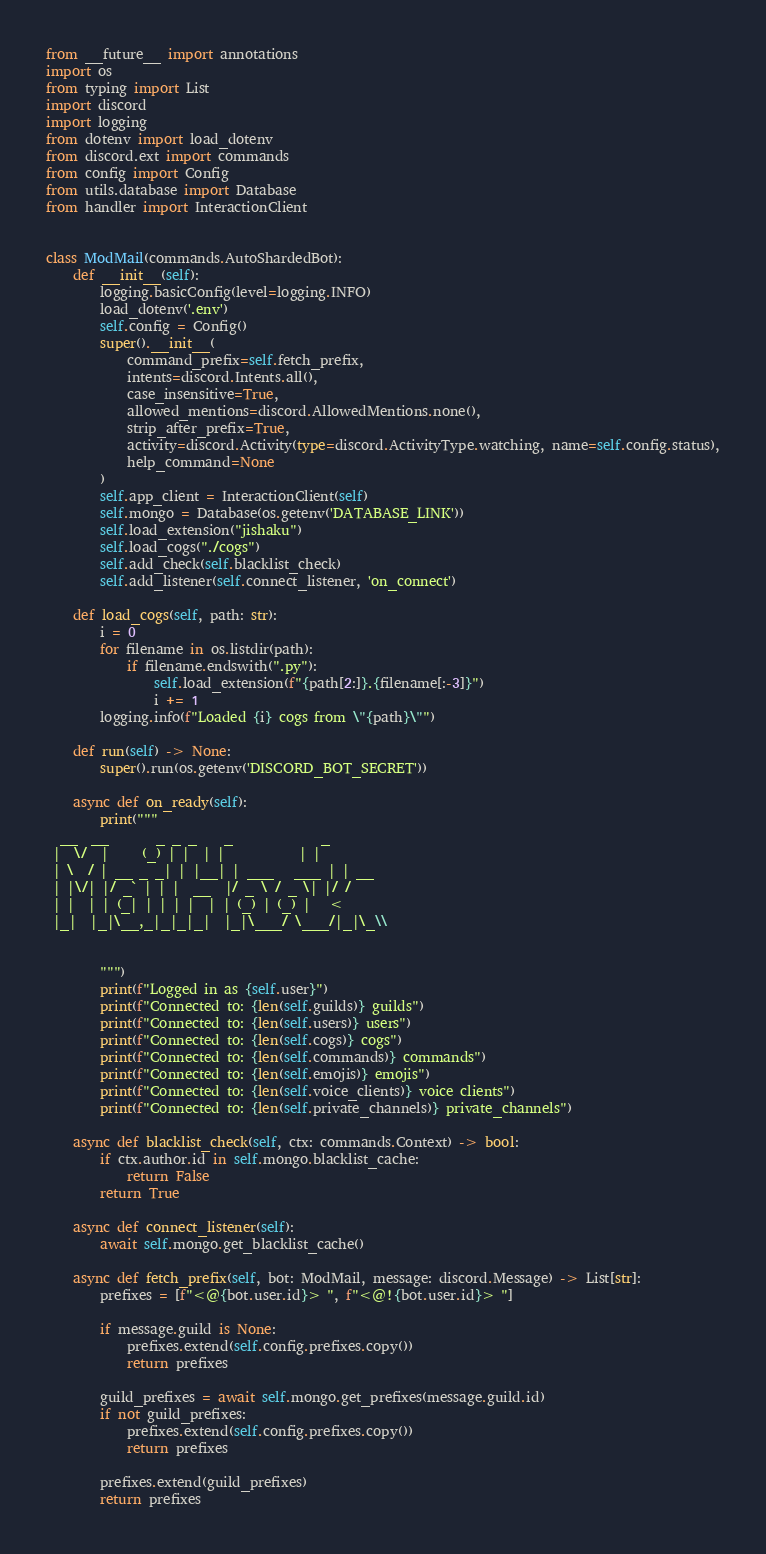Convert code to text. <code><loc_0><loc_0><loc_500><loc_500><_Python_>from __future__ import annotations
import os
from typing import List
import discord
import logging
from dotenv import load_dotenv
from discord.ext import commands
from config import Config
from utils.database import Database
from handler import InteractionClient


class ModMail(commands.AutoShardedBot):
    def __init__(self):
        logging.basicConfig(level=logging.INFO)
        load_dotenv('.env')
        self.config = Config()
        super().__init__(
            command_prefix=self.fetch_prefix,
            intents=discord.Intents.all(),
            case_insensitive=True,
            allowed_mentions=discord.AllowedMentions.none(),
            strip_after_prefix=True,
            activity=discord.Activity(type=discord.ActivityType.watching, name=self.config.status),
            help_command=None
        )
        self.app_client = InteractionClient(self)
        self.mongo = Database(os.getenv('DATABASE_LINK'))
        self.load_extension("jishaku")
        self.load_cogs("./cogs")
        self.add_check(self.blacklist_check)
        self.add_listener(self.connect_listener, 'on_connect')

    def load_cogs(self, path: str):
        i = 0
        for filename in os.listdir(path):
            if filename.endswith(".py"):
                self.load_extension(f"{path[2:]}.{filename[:-3]}")
                i += 1
        logging.info(f"Loaded {i} cogs from \"{path}\"")

    def run(self) -> None:
        super().run(os.getenv('DISCORD_BOT_SECRET'))

    async def on_ready(self):
        print("""
  __  __       _ _ _    _             _
 |  \/  |     (_) | |  | |           | |
 | \  / | __ _ _| | |__| | ___   ___ | | __
 | |\/| |/ _` | | |  __  |/ _ \ / _ \| |/ /
 | |  | | (_| | | | |  | | (_) | (_) |   <
 |_|  |_|\__,_|_|_|_|  |_|\___/ \___/|_|\_\\


        """)
        print(f"Logged in as {self.user}")
        print(f"Connected to: {len(self.guilds)} guilds")
        print(f"Connected to: {len(self.users)} users")
        print(f"Connected to: {len(self.cogs)} cogs")
        print(f"Connected to: {len(self.commands)} commands")
        print(f"Connected to: {len(self.emojis)} emojis")
        print(f"Connected to: {len(self.voice_clients)} voice clients")
        print(f"Connected to: {len(self.private_channels)} private_channels")

    async def blacklist_check(self, ctx: commands.Context) -> bool:
        if ctx.author.id in self.mongo.blacklist_cache:
            return False
        return True

    async def connect_listener(self):
        await self.mongo.get_blacklist_cache()

    async def fetch_prefix(self, bot: ModMail, message: discord.Message) -> List[str]:
        prefixes = [f"<@{bot.user.id}> ", f"<@!{bot.user.id}> "]

        if message.guild is None:
            prefixes.extend(self.config.prefixes.copy())
            return prefixes

        guild_prefixes = await self.mongo.get_prefixes(message.guild.id)
        if not guild_prefixes:
            prefixes.extend(self.config.prefixes.copy())
            return prefixes

        prefixes.extend(guild_prefixes)
        return prefixes
</code> 